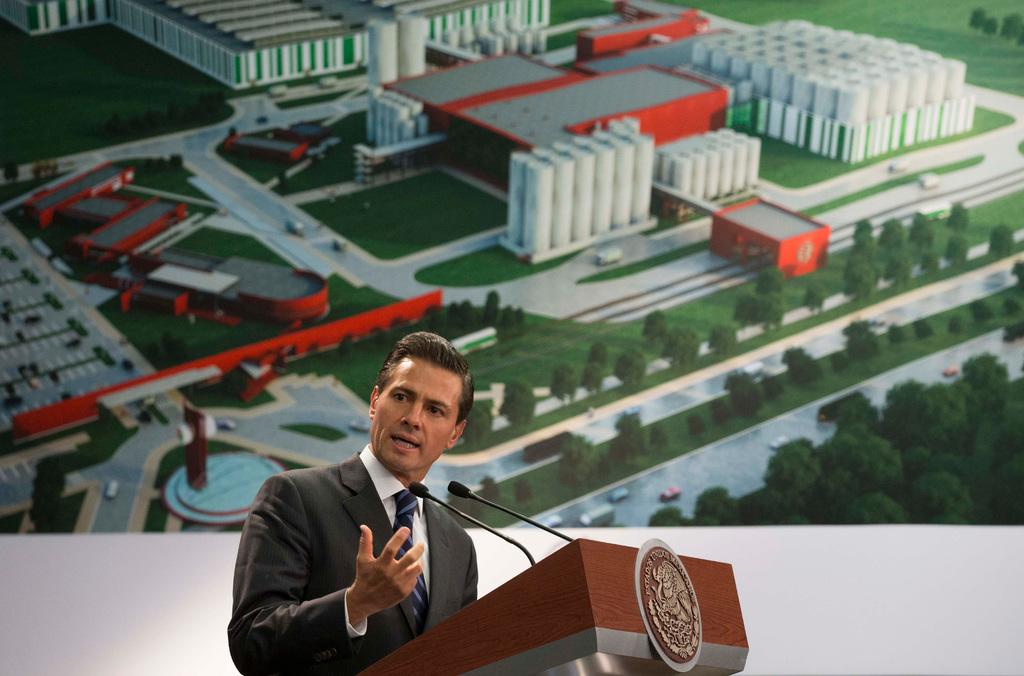What can be seen in the background of the image? There is a board in the background of the image. Who is present in the image? There is a man in the image. What is the man wearing? The man is wearing a shirt, a tie, and a blazer. What is the man doing in the image? The man is standing and talking. What object is present in the image that the man might be using? There is a podium in the image. What objects are present in the image that might be used for amplifying sound? There are microphones in the image. How many bombs can be seen in the image? There are no bombs present in the image. What type of shock is the man experiencing in the image? There is no indication of the man experiencing any shock in the image. 